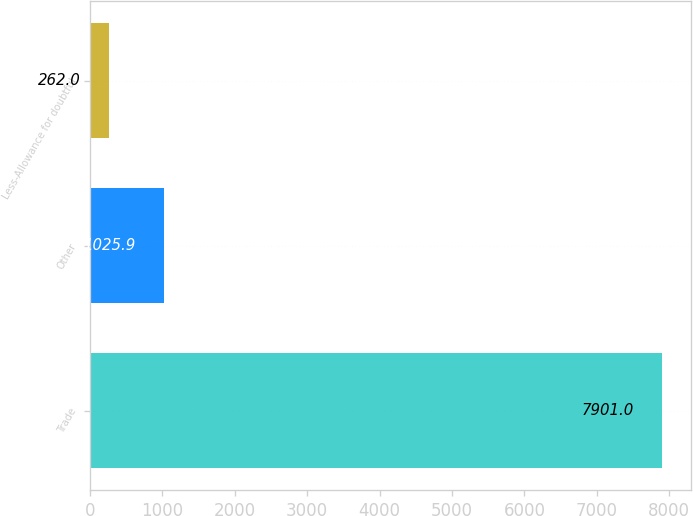<chart> <loc_0><loc_0><loc_500><loc_500><bar_chart><fcel>Trade<fcel>Other<fcel>Less-Allowance for doubtful<nl><fcel>7901<fcel>1025.9<fcel>262<nl></chart> 